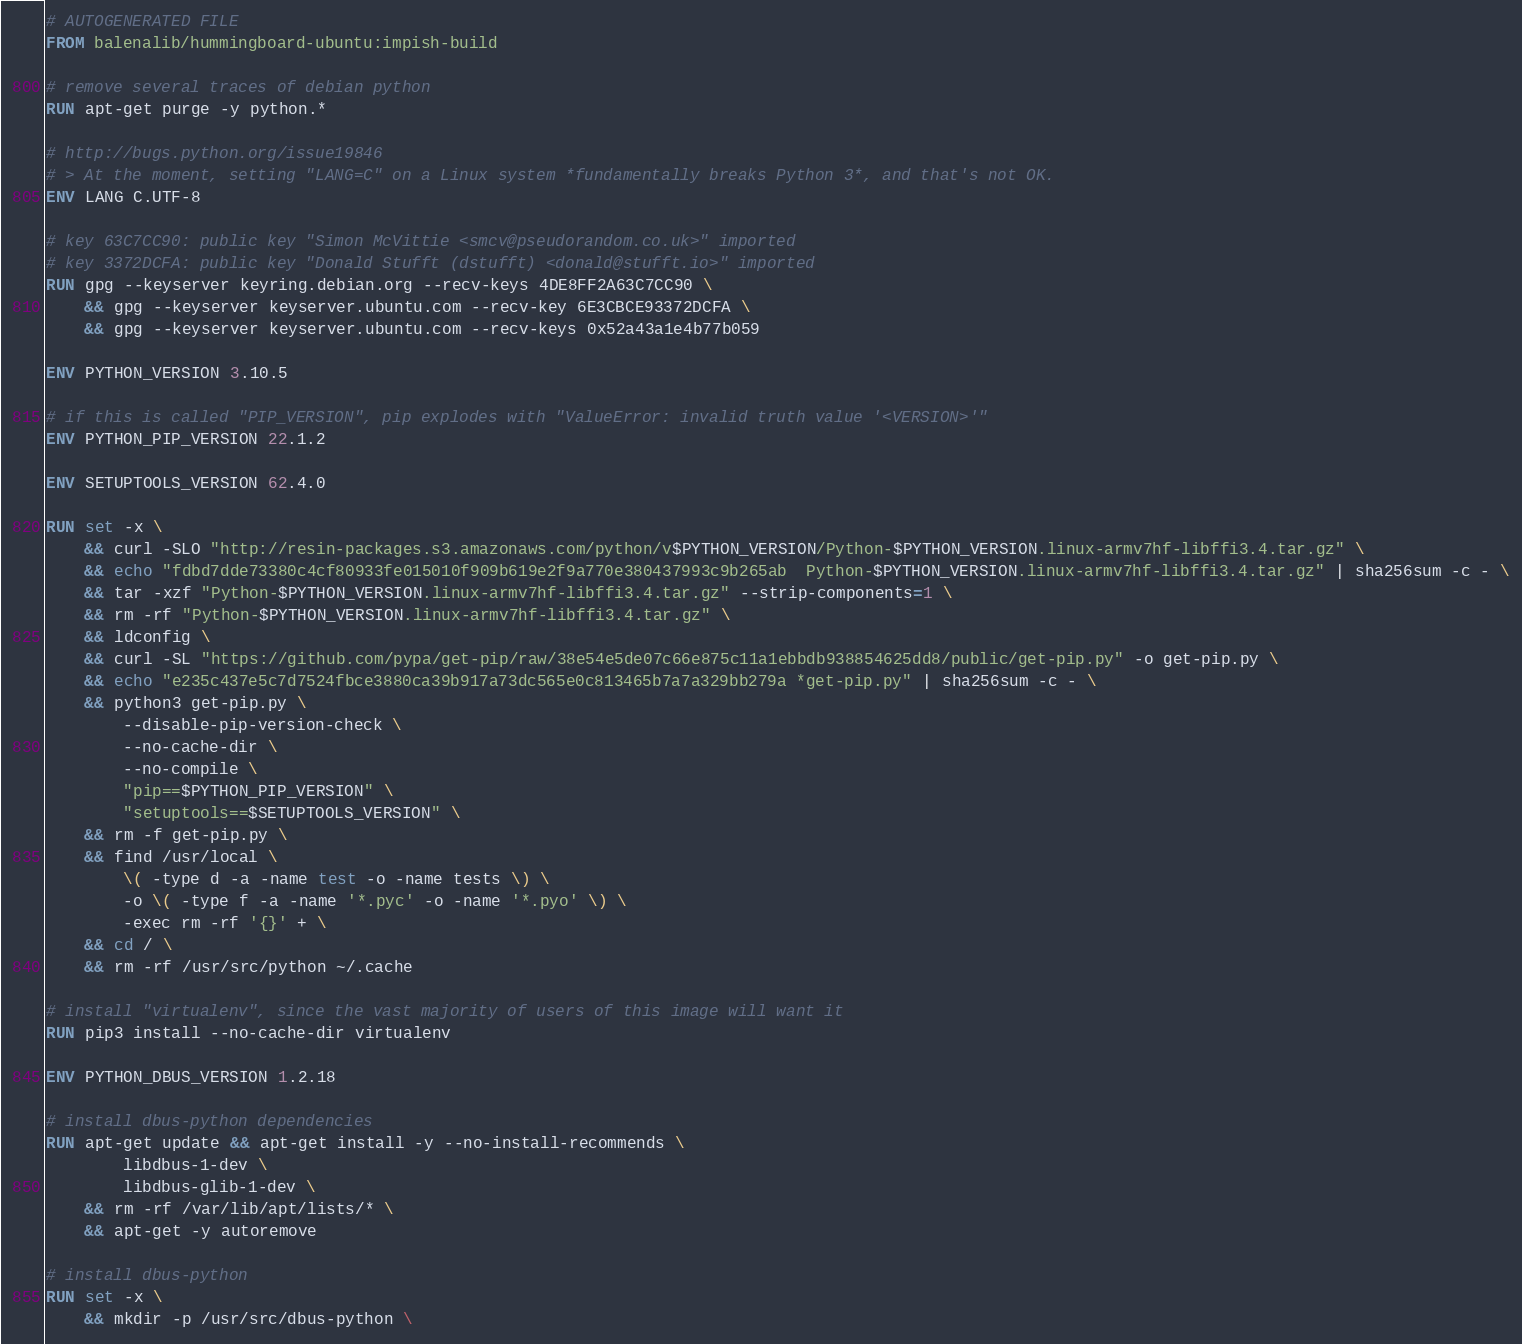<code> <loc_0><loc_0><loc_500><loc_500><_Dockerfile_># AUTOGENERATED FILE
FROM balenalib/hummingboard-ubuntu:impish-build

# remove several traces of debian python
RUN apt-get purge -y python.*

# http://bugs.python.org/issue19846
# > At the moment, setting "LANG=C" on a Linux system *fundamentally breaks Python 3*, and that's not OK.
ENV LANG C.UTF-8

# key 63C7CC90: public key "Simon McVittie <smcv@pseudorandom.co.uk>" imported
# key 3372DCFA: public key "Donald Stufft (dstufft) <donald@stufft.io>" imported
RUN gpg --keyserver keyring.debian.org --recv-keys 4DE8FF2A63C7CC90 \
	&& gpg --keyserver keyserver.ubuntu.com --recv-key 6E3CBCE93372DCFA \
	&& gpg --keyserver keyserver.ubuntu.com --recv-keys 0x52a43a1e4b77b059

ENV PYTHON_VERSION 3.10.5

# if this is called "PIP_VERSION", pip explodes with "ValueError: invalid truth value '<VERSION>'"
ENV PYTHON_PIP_VERSION 22.1.2

ENV SETUPTOOLS_VERSION 62.4.0

RUN set -x \
	&& curl -SLO "http://resin-packages.s3.amazonaws.com/python/v$PYTHON_VERSION/Python-$PYTHON_VERSION.linux-armv7hf-libffi3.4.tar.gz" \
	&& echo "fdbd7dde73380c4cf80933fe015010f909b619e2f9a770e380437993c9b265ab  Python-$PYTHON_VERSION.linux-armv7hf-libffi3.4.tar.gz" | sha256sum -c - \
	&& tar -xzf "Python-$PYTHON_VERSION.linux-armv7hf-libffi3.4.tar.gz" --strip-components=1 \
	&& rm -rf "Python-$PYTHON_VERSION.linux-armv7hf-libffi3.4.tar.gz" \
	&& ldconfig \
	&& curl -SL "https://github.com/pypa/get-pip/raw/38e54e5de07c66e875c11a1ebbdb938854625dd8/public/get-pip.py" -o get-pip.py \
    && echo "e235c437e5c7d7524fbce3880ca39b917a73dc565e0c813465b7a7a329bb279a *get-pip.py" | sha256sum -c - \
    && python3 get-pip.py \
        --disable-pip-version-check \
        --no-cache-dir \
        --no-compile \
        "pip==$PYTHON_PIP_VERSION" \
        "setuptools==$SETUPTOOLS_VERSION" \
	&& rm -f get-pip.py \
	&& find /usr/local \
		\( -type d -a -name test -o -name tests \) \
		-o \( -type f -a -name '*.pyc' -o -name '*.pyo' \) \
		-exec rm -rf '{}' + \
	&& cd / \
	&& rm -rf /usr/src/python ~/.cache

# install "virtualenv", since the vast majority of users of this image will want it
RUN pip3 install --no-cache-dir virtualenv

ENV PYTHON_DBUS_VERSION 1.2.18

# install dbus-python dependencies 
RUN apt-get update && apt-get install -y --no-install-recommends \
		libdbus-1-dev \
		libdbus-glib-1-dev \
	&& rm -rf /var/lib/apt/lists/* \
	&& apt-get -y autoremove

# install dbus-python
RUN set -x \
	&& mkdir -p /usr/src/dbus-python \</code> 